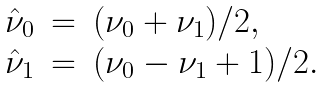Convert formula to latex. <formula><loc_0><loc_0><loc_500><loc_500>\begin{array} { l l l } \hat { \nu } _ { 0 } & = & ( \nu _ { 0 } + \nu _ { 1 } ) / 2 , \\ \hat { \nu } _ { 1 } & = & ( \nu _ { 0 } - \nu _ { 1 } + 1 ) / 2 . \\ \end{array}</formula> 